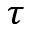Convert formula to latex. <formula><loc_0><loc_0><loc_500><loc_500>\tau</formula> 